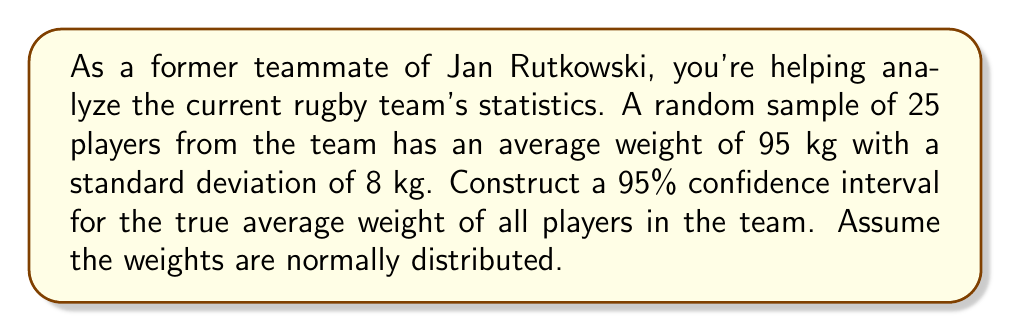Give your solution to this math problem. To construct a 95% confidence interval, we'll follow these steps:

1) The formula for a confidence interval is:

   $$\bar{x} \pm t_{\alpha/2} \cdot \frac{s}{\sqrt{n}}$$

   Where:
   $\bar{x}$ is the sample mean
   $t_{\alpha/2}$ is the t-value for the desired confidence level
   $s$ is the sample standard deviation
   $n$ is the sample size

2) We have:
   $\bar{x} = 95$ kg
   $s = 8$ kg
   $n = 25$
   Confidence level = 95% (so $\alpha = 0.05$)

3) For a 95% confidence interval with 24 degrees of freedom (n-1), the t-value is approximately 2.064 (from t-distribution table).

4) Now, let's calculate the margin of error:

   $$2.064 \cdot \frac{8}{\sqrt{25}} = 2.064 \cdot \frac{8}{5} = 3.3024$$

5) Therefore, the confidence interval is:

   $$95 \pm 3.3024$$

6) This gives us the interval:

   $$(95 - 3.3024, 95 + 3.3024) = (91.6976, 98.3024)$$
Answer: (91.70 kg, 98.30 kg) 